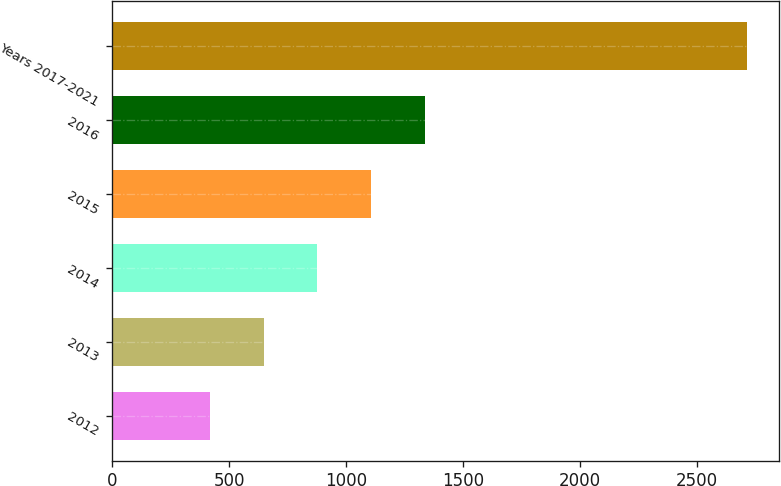Convert chart. <chart><loc_0><loc_0><loc_500><loc_500><bar_chart><fcel>2012<fcel>2013<fcel>2014<fcel>2015<fcel>2016<fcel>Years 2017-2021<nl><fcel>417<fcel>646.6<fcel>876.2<fcel>1105.8<fcel>1335.4<fcel>2713<nl></chart> 